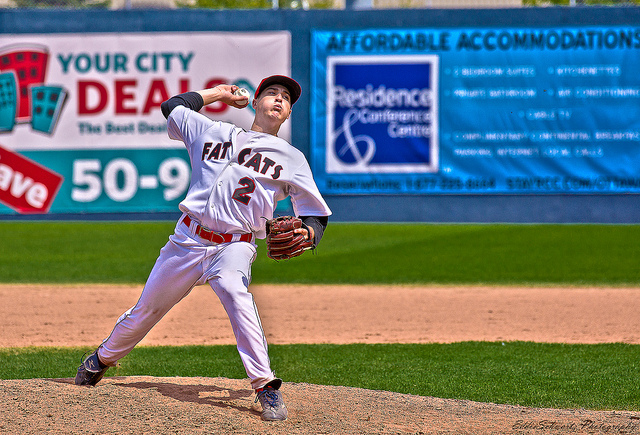Please extract the text content from this image. FAT CATS 2 50 YOUR ACCOMMODATIONS AFFORDABLE RESIDENCE AVE 9 DEALS CITY 